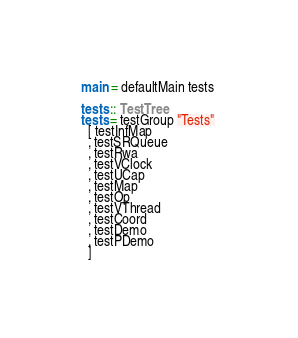Convert code to text. <code><loc_0><loc_0><loc_500><loc_500><_Haskell_>
main = defaultMain tests

tests :: TestTree
tests = testGroup "Tests" 
  [ testInfMap
  , testSRQueue
  , testRwa
  , testVClock
  , testUCap
  , testMap
  , testOp
  , testVThread
  , testCoord
  , testDemo
  , testPDemo
  ]
</code> 